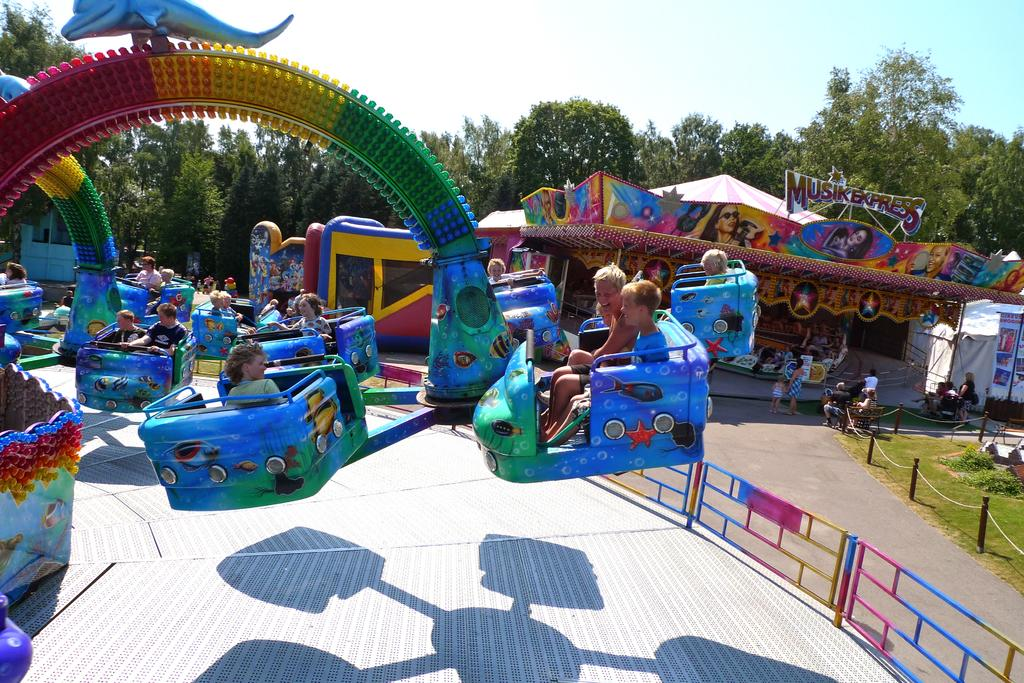What type of attractions can be seen in the image? There are amusement rides in the image. What are the people in the image doing? People are taking the rides in the image. What can be seen in the background of the image? There are trees and the sky visible in the background of the image. Where is the store located in the image? There is no store present in the image; it features amusement rides and people taking the rides. What type of trail can be seen in the image? There is no trail present in the image; it features amusement rides, people taking the rides, trees, and the sky. 